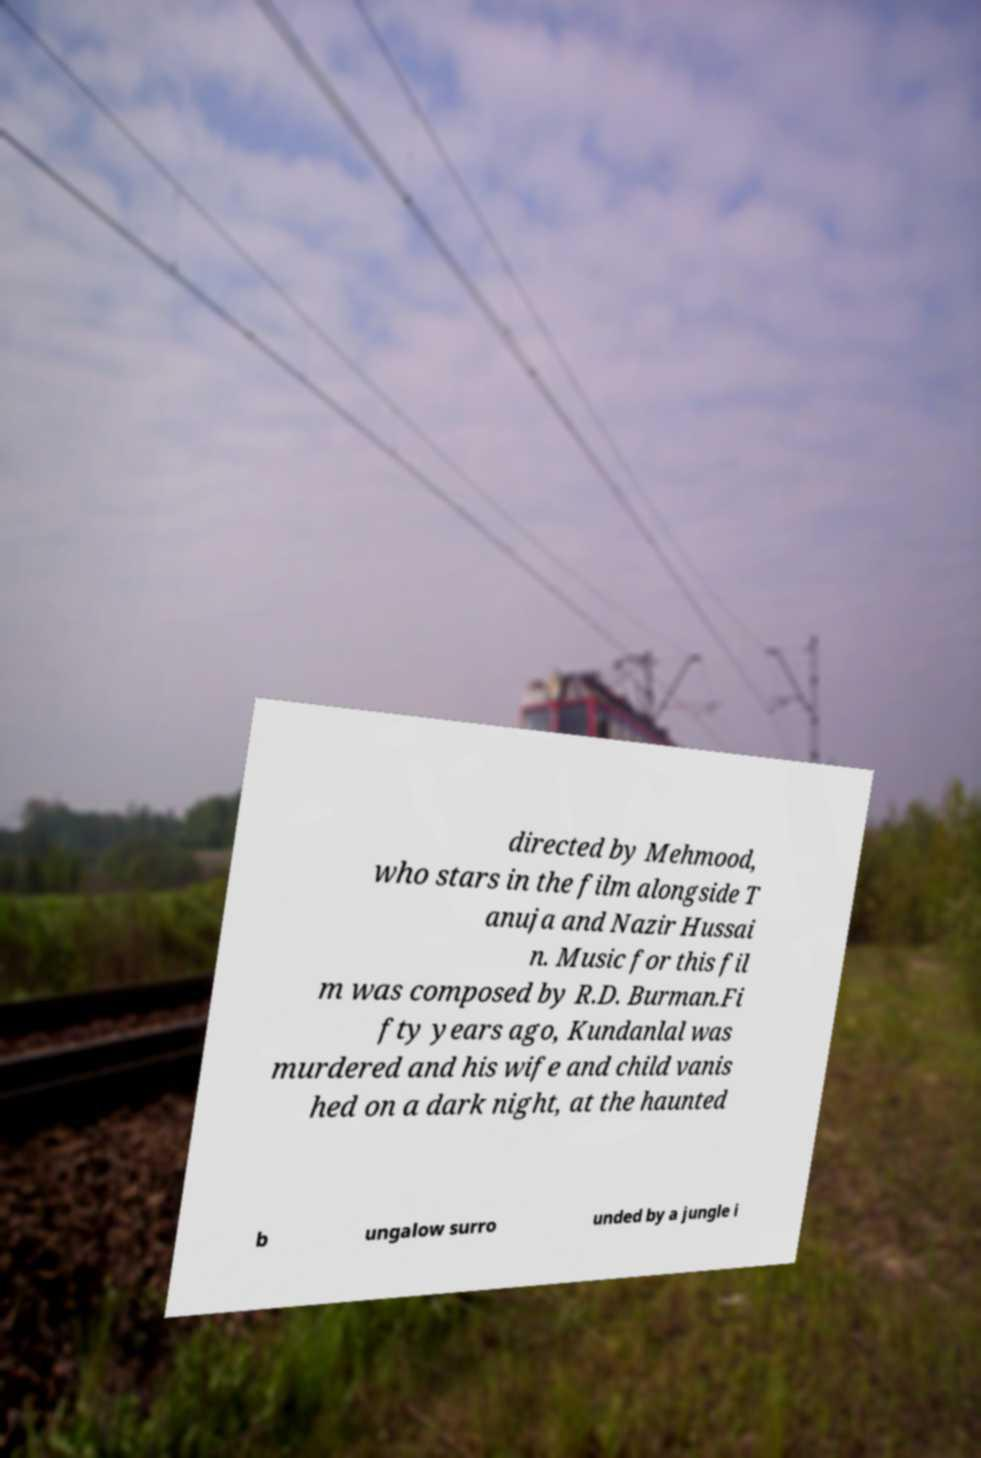There's text embedded in this image that I need extracted. Can you transcribe it verbatim? directed by Mehmood, who stars in the film alongside T anuja and Nazir Hussai n. Music for this fil m was composed by R.D. Burman.Fi fty years ago, Kundanlal was murdered and his wife and child vanis hed on a dark night, at the haunted b ungalow surro unded by a jungle i 